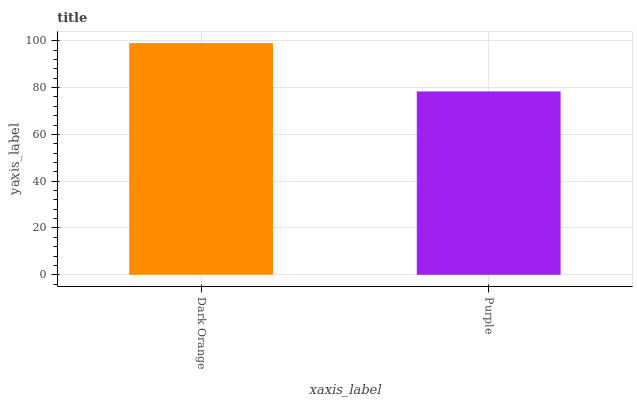Is Purple the maximum?
Answer yes or no. No. Is Dark Orange greater than Purple?
Answer yes or no. Yes. Is Purple less than Dark Orange?
Answer yes or no. Yes. Is Purple greater than Dark Orange?
Answer yes or no. No. Is Dark Orange less than Purple?
Answer yes or no. No. Is Dark Orange the high median?
Answer yes or no. Yes. Is Purple the low median?
Answer yes or no. Yes. Is Purple the high median?
Answer yes or no. No. Is Dark Orange the low median?
Answer yes or no. No. 